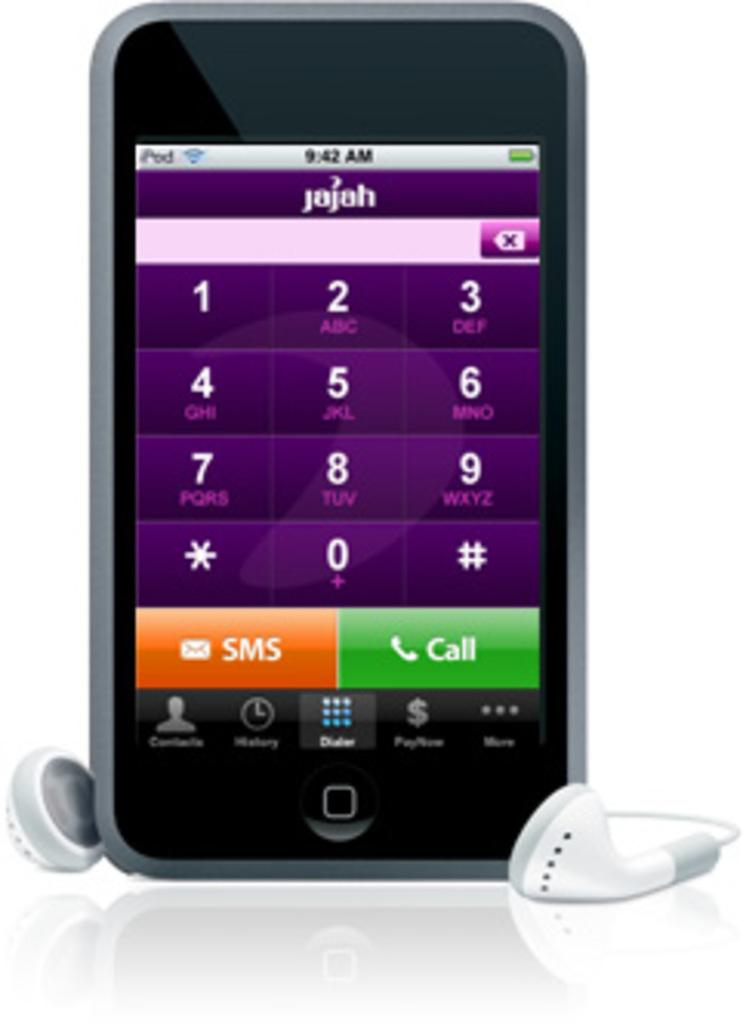Provide a one-sentence caption for the provided image. an ipod showing that it is 9:42 am on it. 